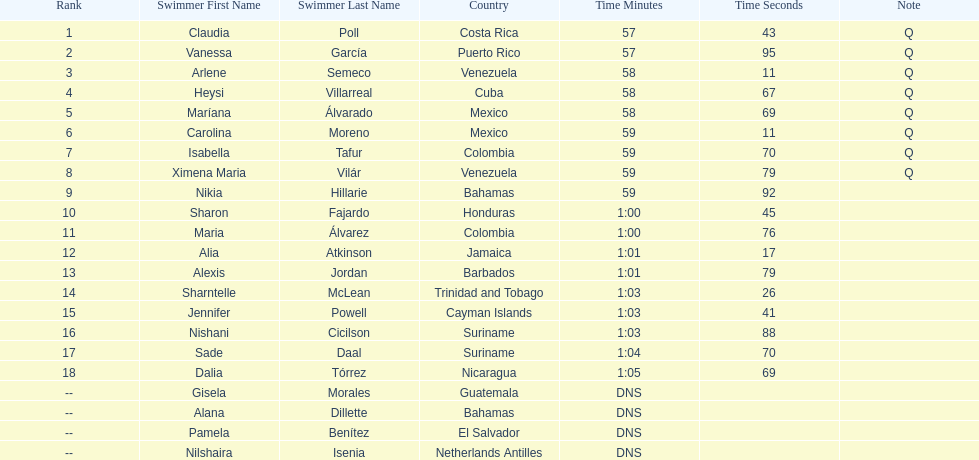Who was the last competitor to actually finish the preliminaries? Dalia Tórrez. 